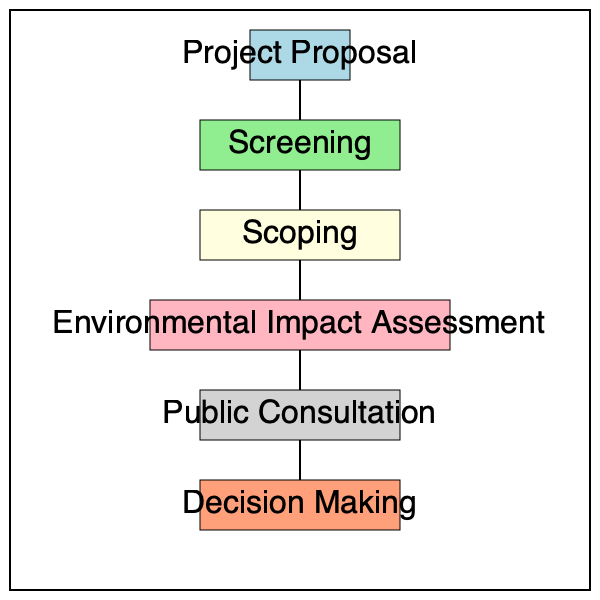In the environmental impact assessment process for new industrial projects, which step immediately follows the scoping phase and involves a comprehensive analysis of potential environmental effects? The environmental impact assessment process for new industrial projects typically follows a specific sequence of steps:

1. Project Proposal: The initial stage where the project is conceived and proposed.

2. Screening: This step determines whether a full environmental impact assessment is necessary for the project.

3. Scoping: This phase identifies the key environmental issues that need to be addressed in the assessment.

4. Environmental Impact Assessment: This is the core step that follows scoping. It involves a detailed analysis of the potential environmental effects of the project, including direct, indirect, and cumulative impacts on various environmental components.

5. Public Consultation: After the environmental impact assessment is conducted, the findings are typically shared with the public for feedback and input.

6. Decision Making: The final step where authorities decide whether to approve the project, approve with conditions, or reject it based on the environmental impact assessment and public feedback.

According to the flowchart, the Environmental Impact Assessment step directly follows the Scoping phase. This is the stage where a comprehensive analysis of potential environmental effects is conducted, making it the correct answer to the question.
Answer: Environmental Impact Assessment 